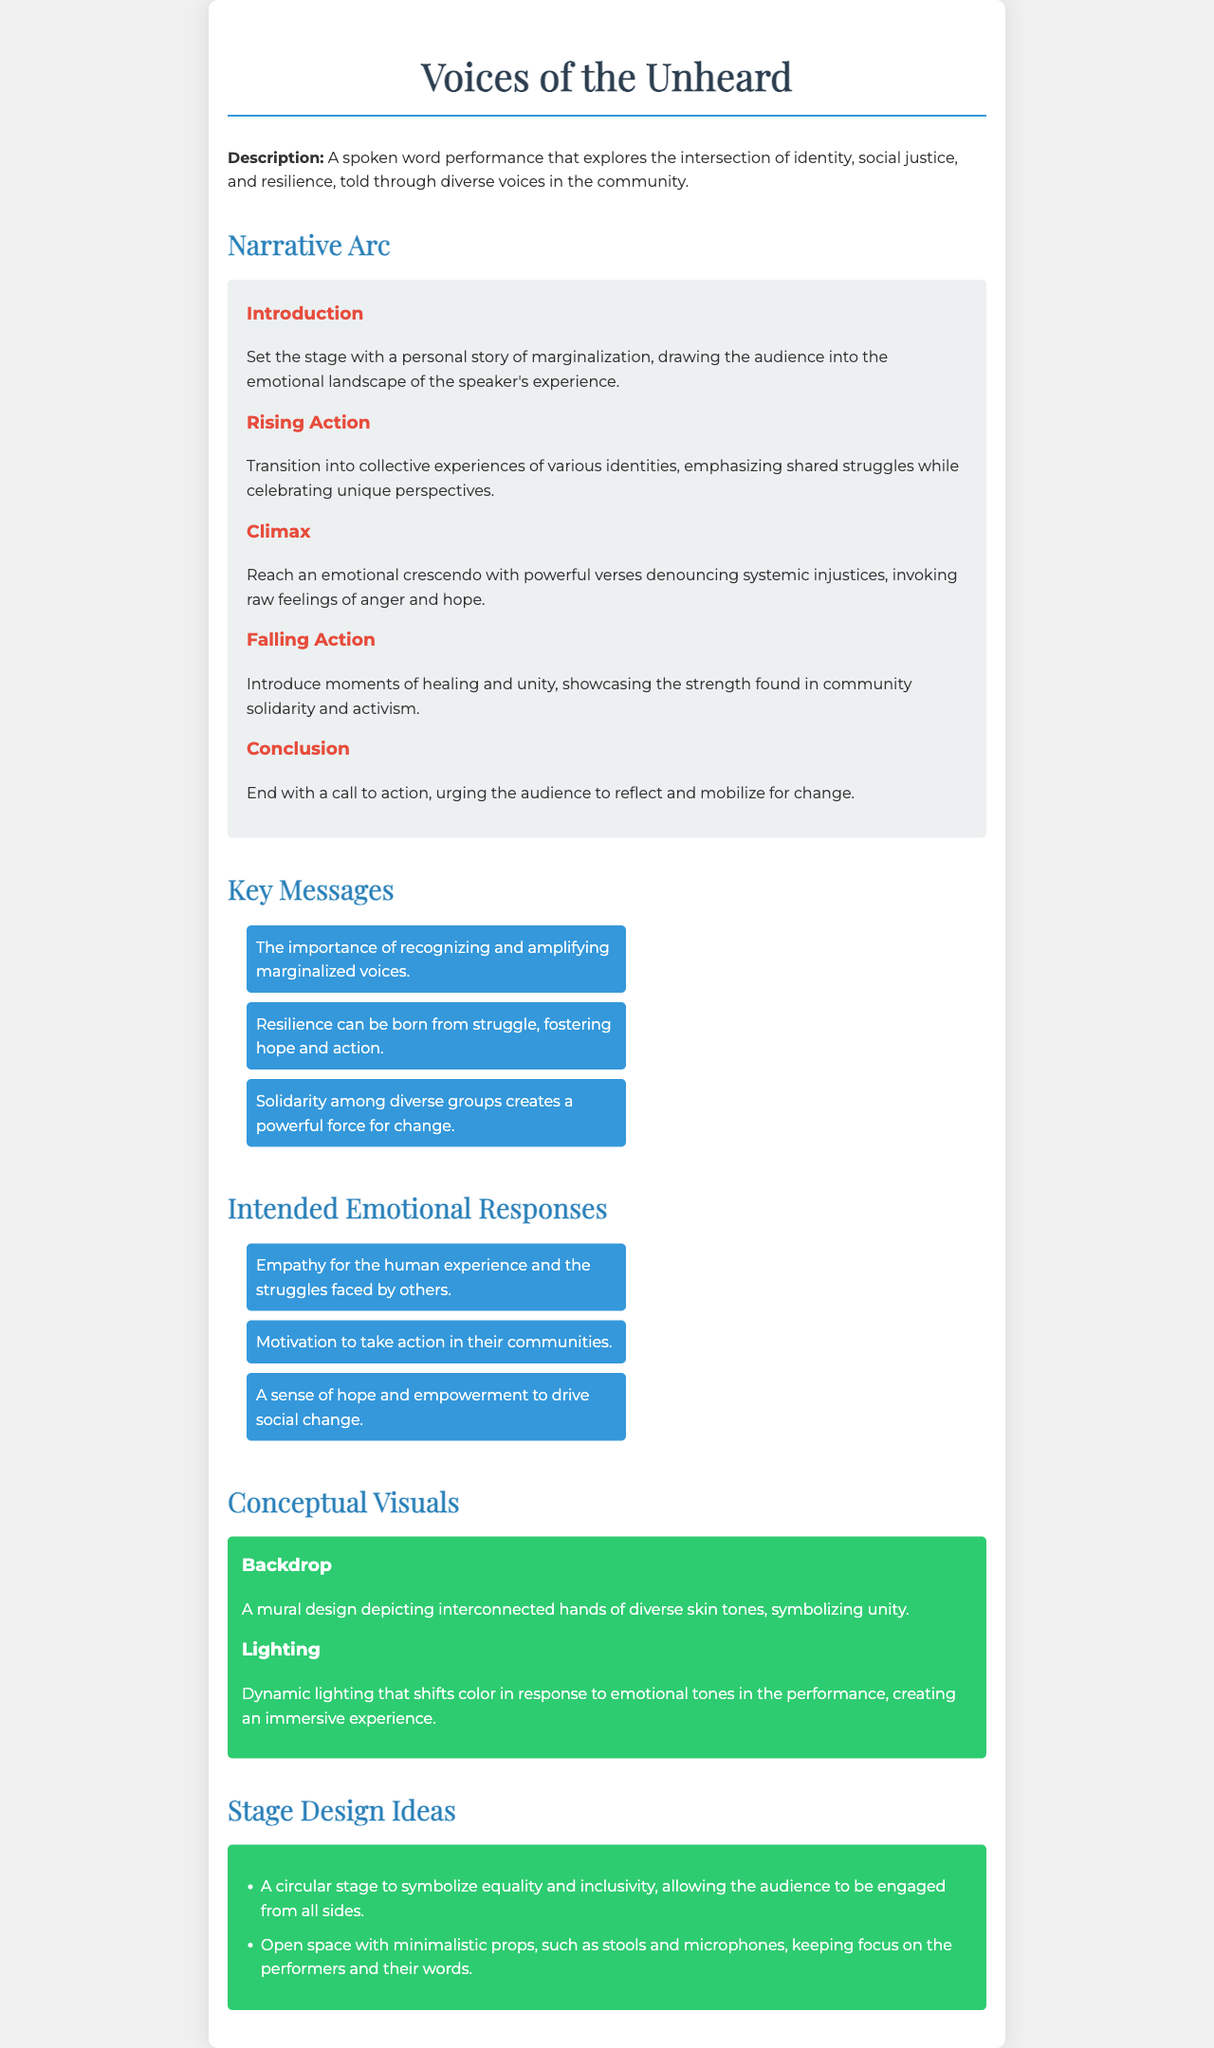what is the title of the performance? The title is prominently displayed at the top of the document.
Answer: Voices of the Unheard what is the primary theme explored in this performance? The theme is outlined in the description section of the document.
Answer: Identity, social justice, and resilience how many key messages are listed in the document? The number of key messages is found in the Key Messages section.
Answer: Three what type of stage design is suggested in the brief? The stage design ideas are provided towards the end of the document.
Answer: Circular stage what emotional response is intended to be evoked? The intended emotional responses are listed in that section.
Answer: Empathy what color is associated with the backdrop concept? The color mentioned for unity representation in the visuals.
Answer: Diverse skin tones in which section does the climax of the narrative arc occur? The climax is specifically detailed under the Narrative Arc section.
Answer: Climax what is the call to action in the conclusion? The conclusion describes the final message the audience should take away.
Answer: Reflect and mobilize for change what type of lighting is described in the conceptual visuals? The visuals section mentions the type of lighting used during the performance.
Answer: Dynamic lighting 